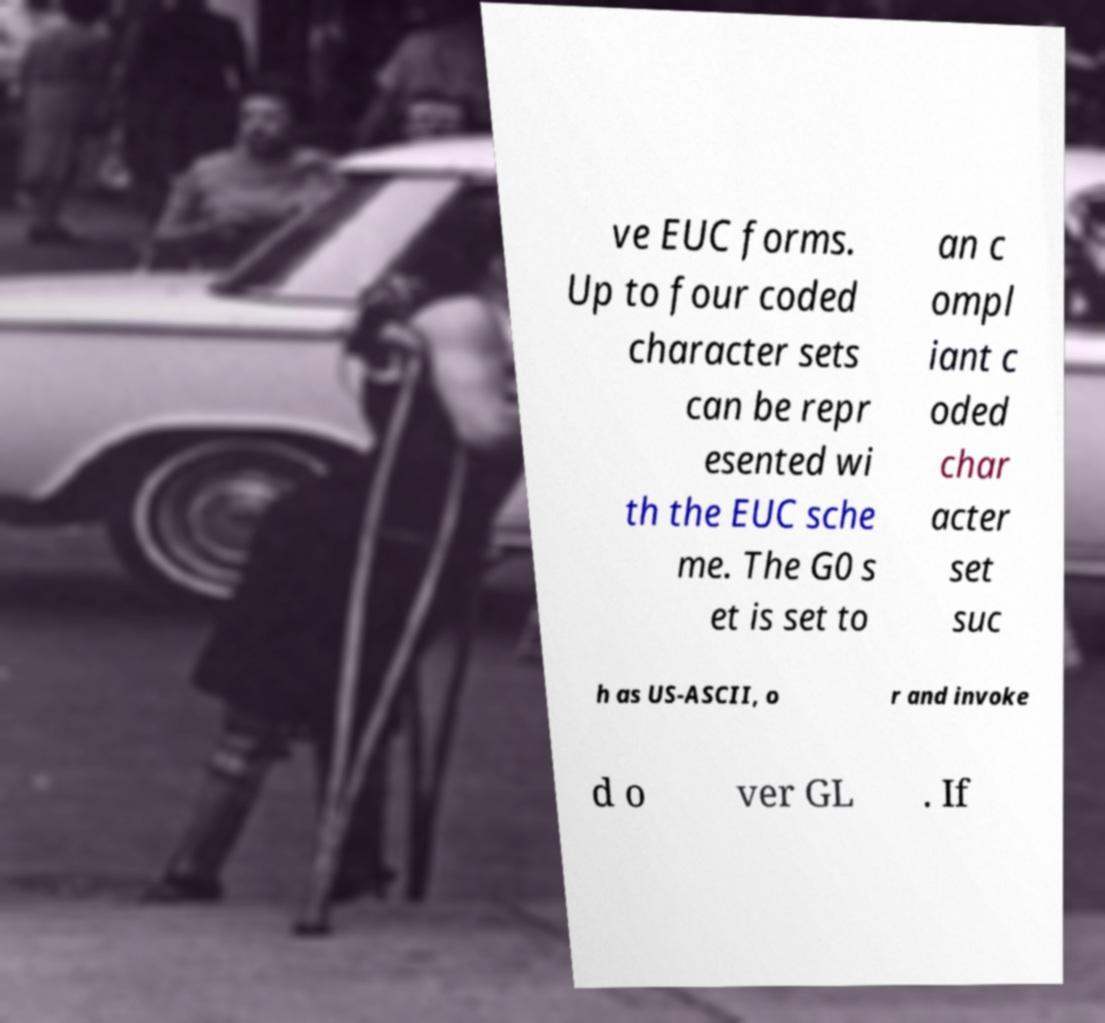For documentation purposes, I need the text within this image transcribed. Could you provide that? ve EUC forms. Up to four coded character sets can be repr esented wi th the EUC sche me. The G0 s et is set to an c ompl iant c oded char acter set suc h as US-ASCII, o r and invoke d o ver GL . If 